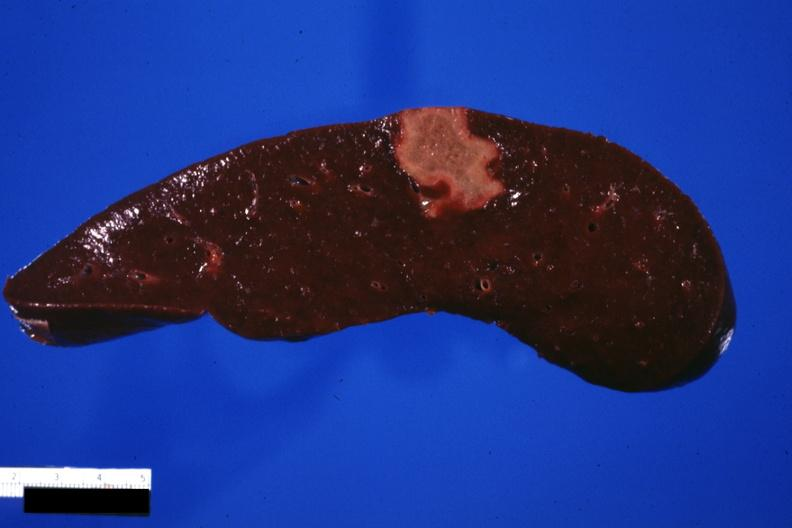how does this image show cut surface of spleen?
Answer the question using a single word or phrase. With an infarct several days age excellent photo 